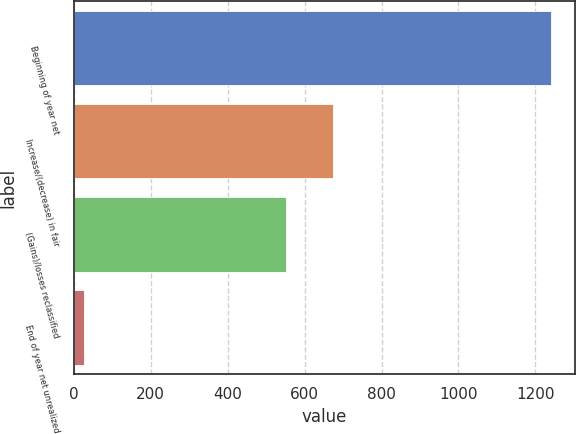Convert chart to OTSL. <chart><loc_0><loc_0><loc_500><loc_500><bar_chart><fcel>Beginning of year net<fcel>Increase/(decrease) in fair<fcel>(Gains)/losses reclassified<fcel>End of year net unrealized<nl><fcel>1240<fcel>674.4<fcel>553<fcel>26<nl></chart> 